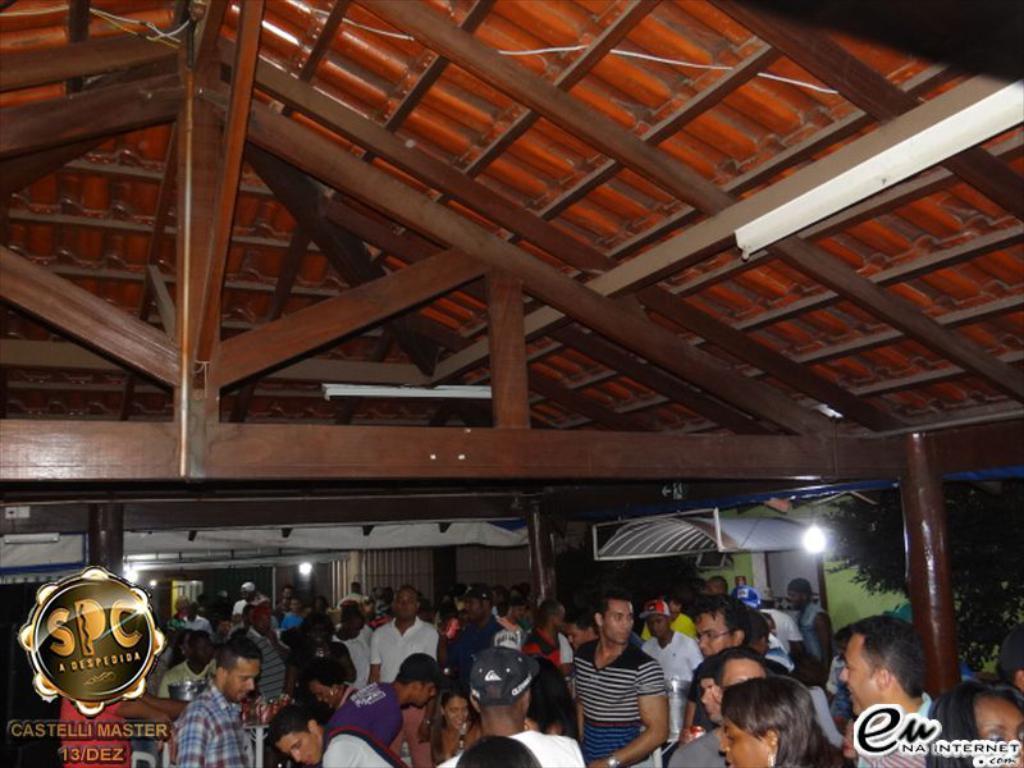In one or two sentences, can you explain what this image depicts? This image is taken indoors. At the top of the image there is a roof and there are a few iron bars. In the background there are a few walls with doors. There are a few lights. There are a few pillars. On the right side of the image there is a tree and there is a watermark. On the left side of the image there is a bookmark. In the middle of the image many people are standing. 